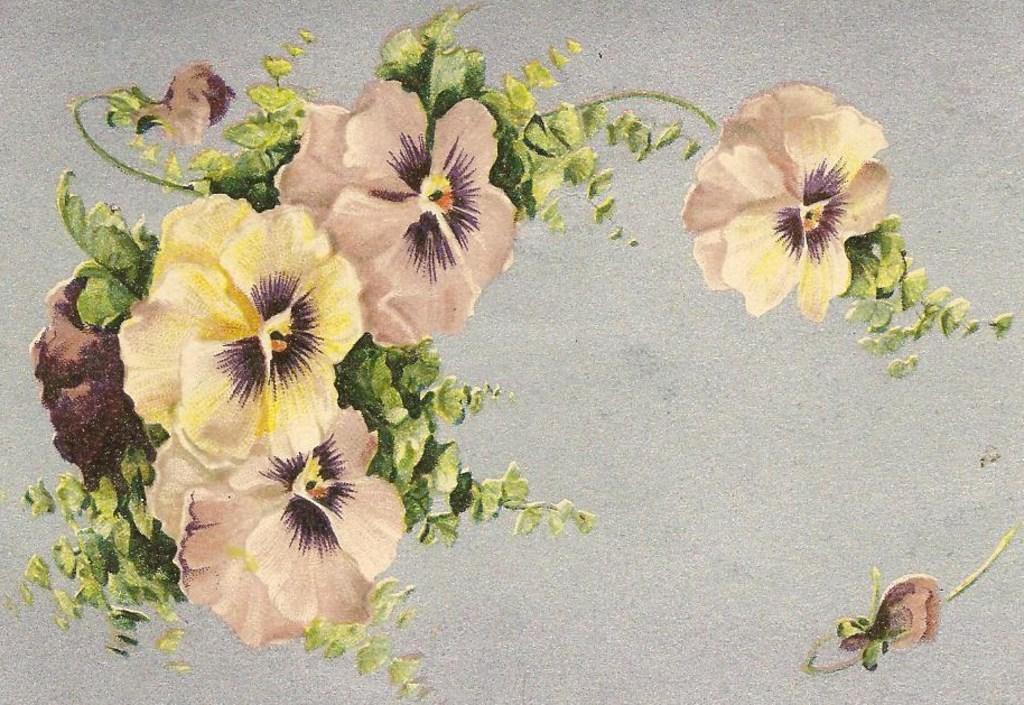Can you describe this image briefly? This image is a painting. In this painting we can see flowers and leaves. 